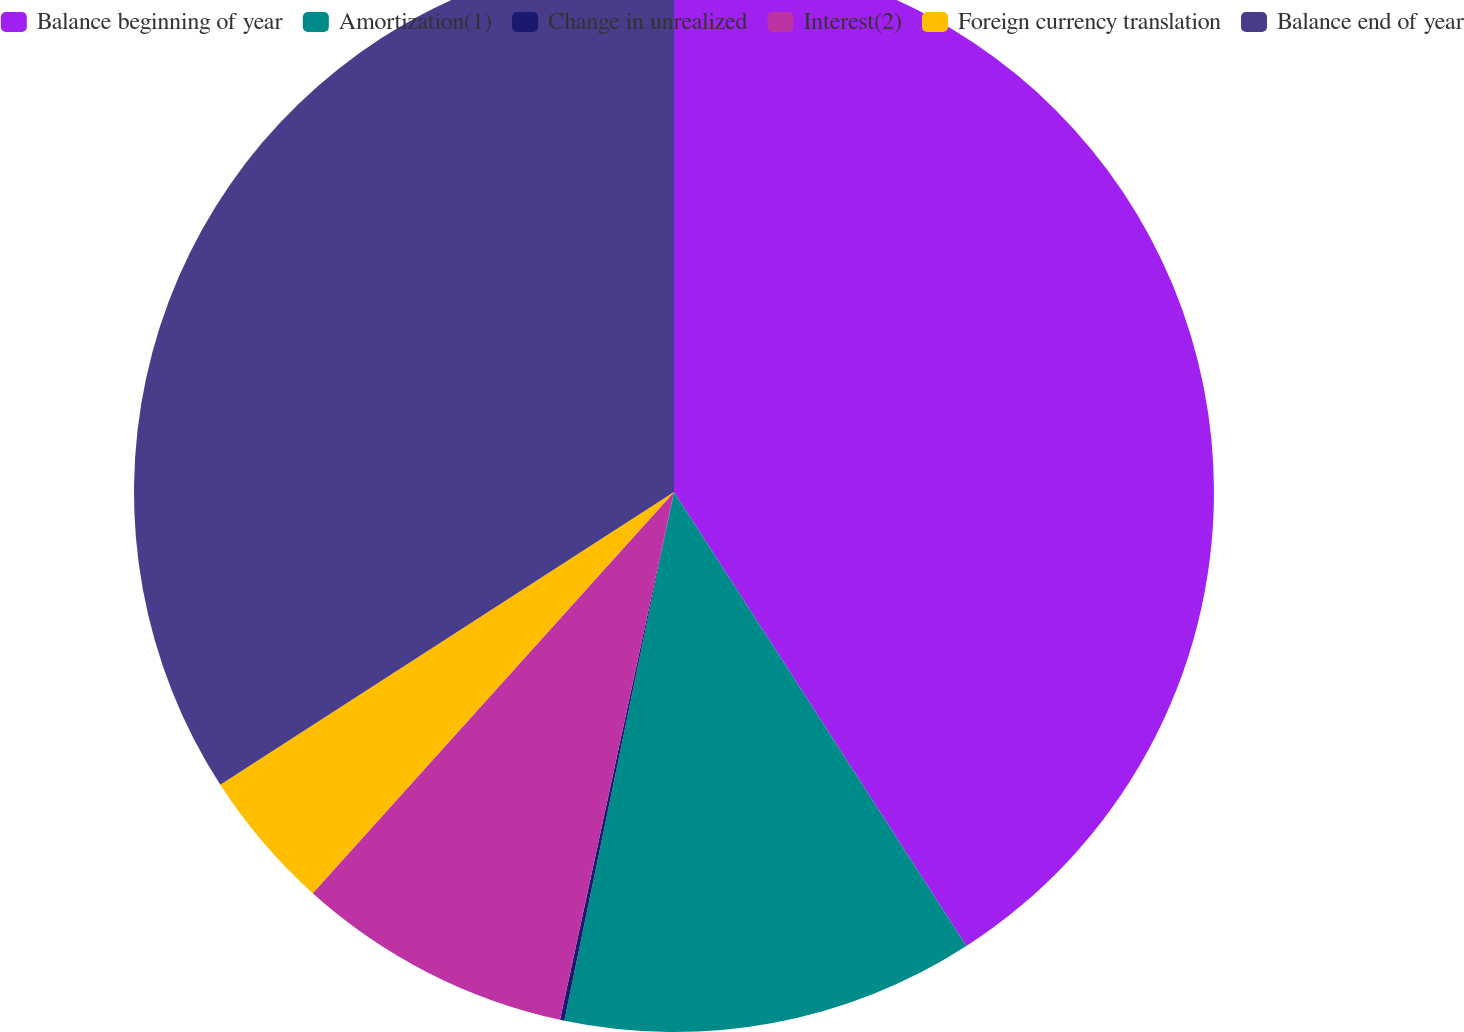<chart> <loc_0><loc_0><loc_500><loc_500><pie_chart><fcel>Balance beginning of year<fcel>Amortization(1)<fcel>Change in unrealized<fcel>Interest(2)<fcel>Foreign currency translation<fcel>Balance end of year<nl><fcel>40.89%<fcel>12.36%<fcel>0.13%<fcel>8.28%<fcel>4.21%<fcel>34.12%<nl></chart> 